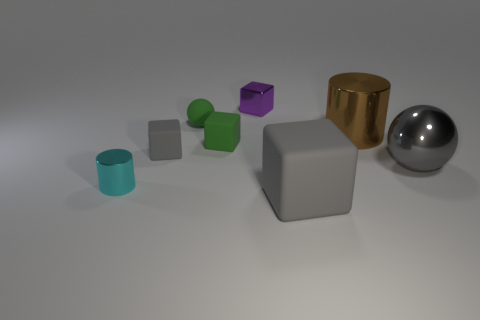There is a tiny gray matte cube; what number of shiny things are to the left of it?
Offer a very short reply. 1. What material is the gray object that is both left of the large brown cylinder and behind the small cyan cylinder?
Your answer should be very brief. Rubber. What number of cylinders are tiny gray matte objects or cyan objects?
Your answer should be compact. 1. What is the material of the small purple thing that is the same shape as the tiny gray matte thing?
Ensure brevity in your answer.  Metal. What is the size of the purple block that is made of the same material as the cyan thing?
Provide a succinct answer. Small. Do the matte object behind the big cylinder and the shiny thing behind the big brown cylinder have the same shape?
Ensure brevity in your answer.  No. There is a big cylinder that is made of the same material as the small cylinder; what color is it?
Give a very brief answer. Brown. There is a green matte block that is to the left of the big sphere; does it have the same size as the metal object that is behind the brown metal cylinder?
Your answer should be very brief. Yes. The shiny object that is in front of the big brown thing and right of the green matte ball has what shape?
Make the answer very short. Sphere. Are there any small green things made of the same material as the small gray block?
Provide a succinct answer. Yes. 